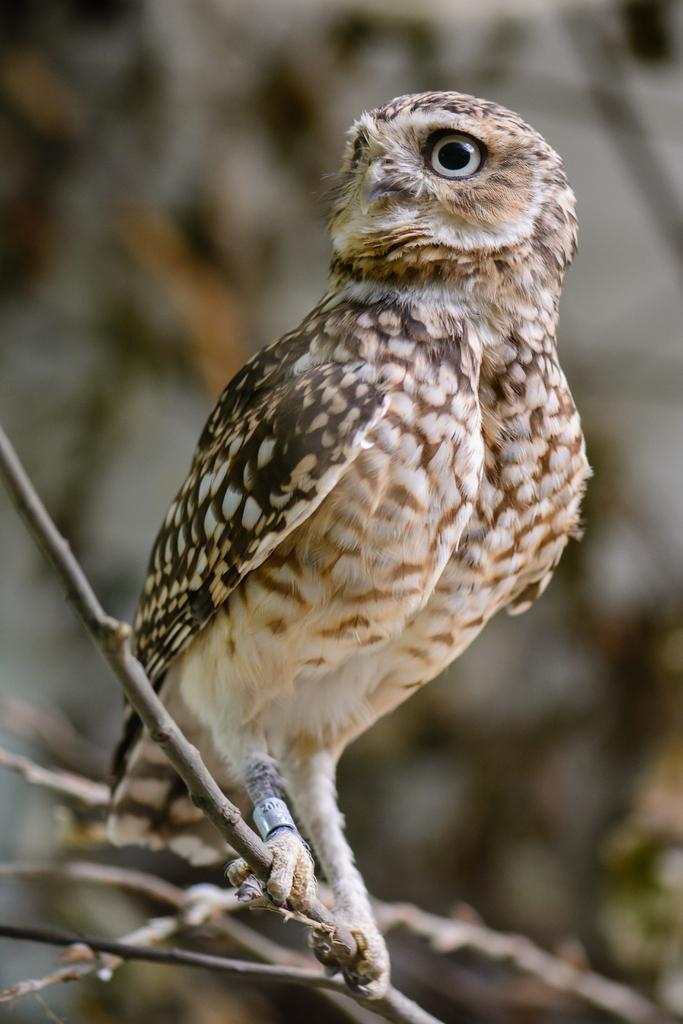What type of animal is present in the image? There is a bird in the image. Where is the bird located? The bird is on a stem. Can you describe the background of the image? The background of the image is blurred. How many icicles are hanging from the bird's beak in the image? There are no icicles present in the image; it features a bird on a stem with a blurred background. 